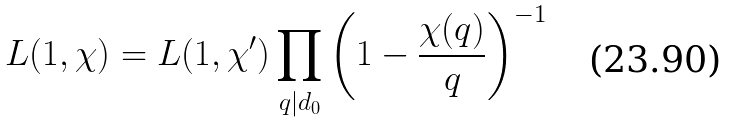<formula> <loc_0><loc_0><loc_500><loc_500>L ( 1 , \chi ) = L ( 1 , \chi ^ { \prime } ) \prod _ { q | d _ { 0 } } \left ( 1 - \frac { \chi ( q ) } { q } \right ) ^ { - 1 }</formula> 